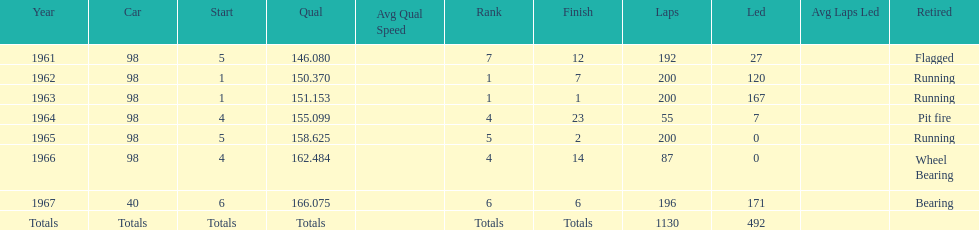What was his best finish before his first win? 7. 